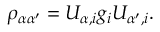Convert formula to latex. <formula><loc_0><loc_0><loc_500><loc_500>\rho _ { \alpha \alpha ^ { \prime } } = U _ { \alpha , i } g _ { i } U _ { \alpha ^ { \prime } , i } .</formula> 